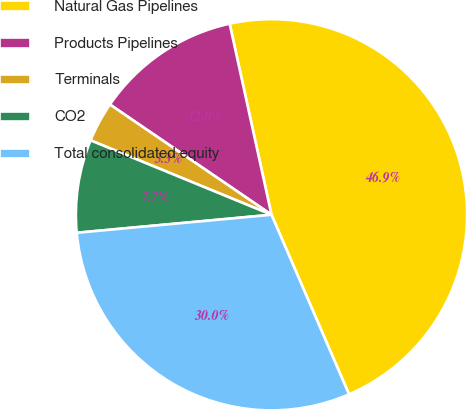Convert chart to OTSL. <chart><loc_0><loc_0><loc_500><loc_500><pie_chart><fcel>Natural Gas Pipelines<fcel>Products Pipelines<fcel>Terminals<fcel>CO2<fcel>Total consolidated equity<nl><fcel>46.95%<fcel>12.04%<fcel>3.32%<fcel>7.68%<fcel>30.02%<nl></chart> 